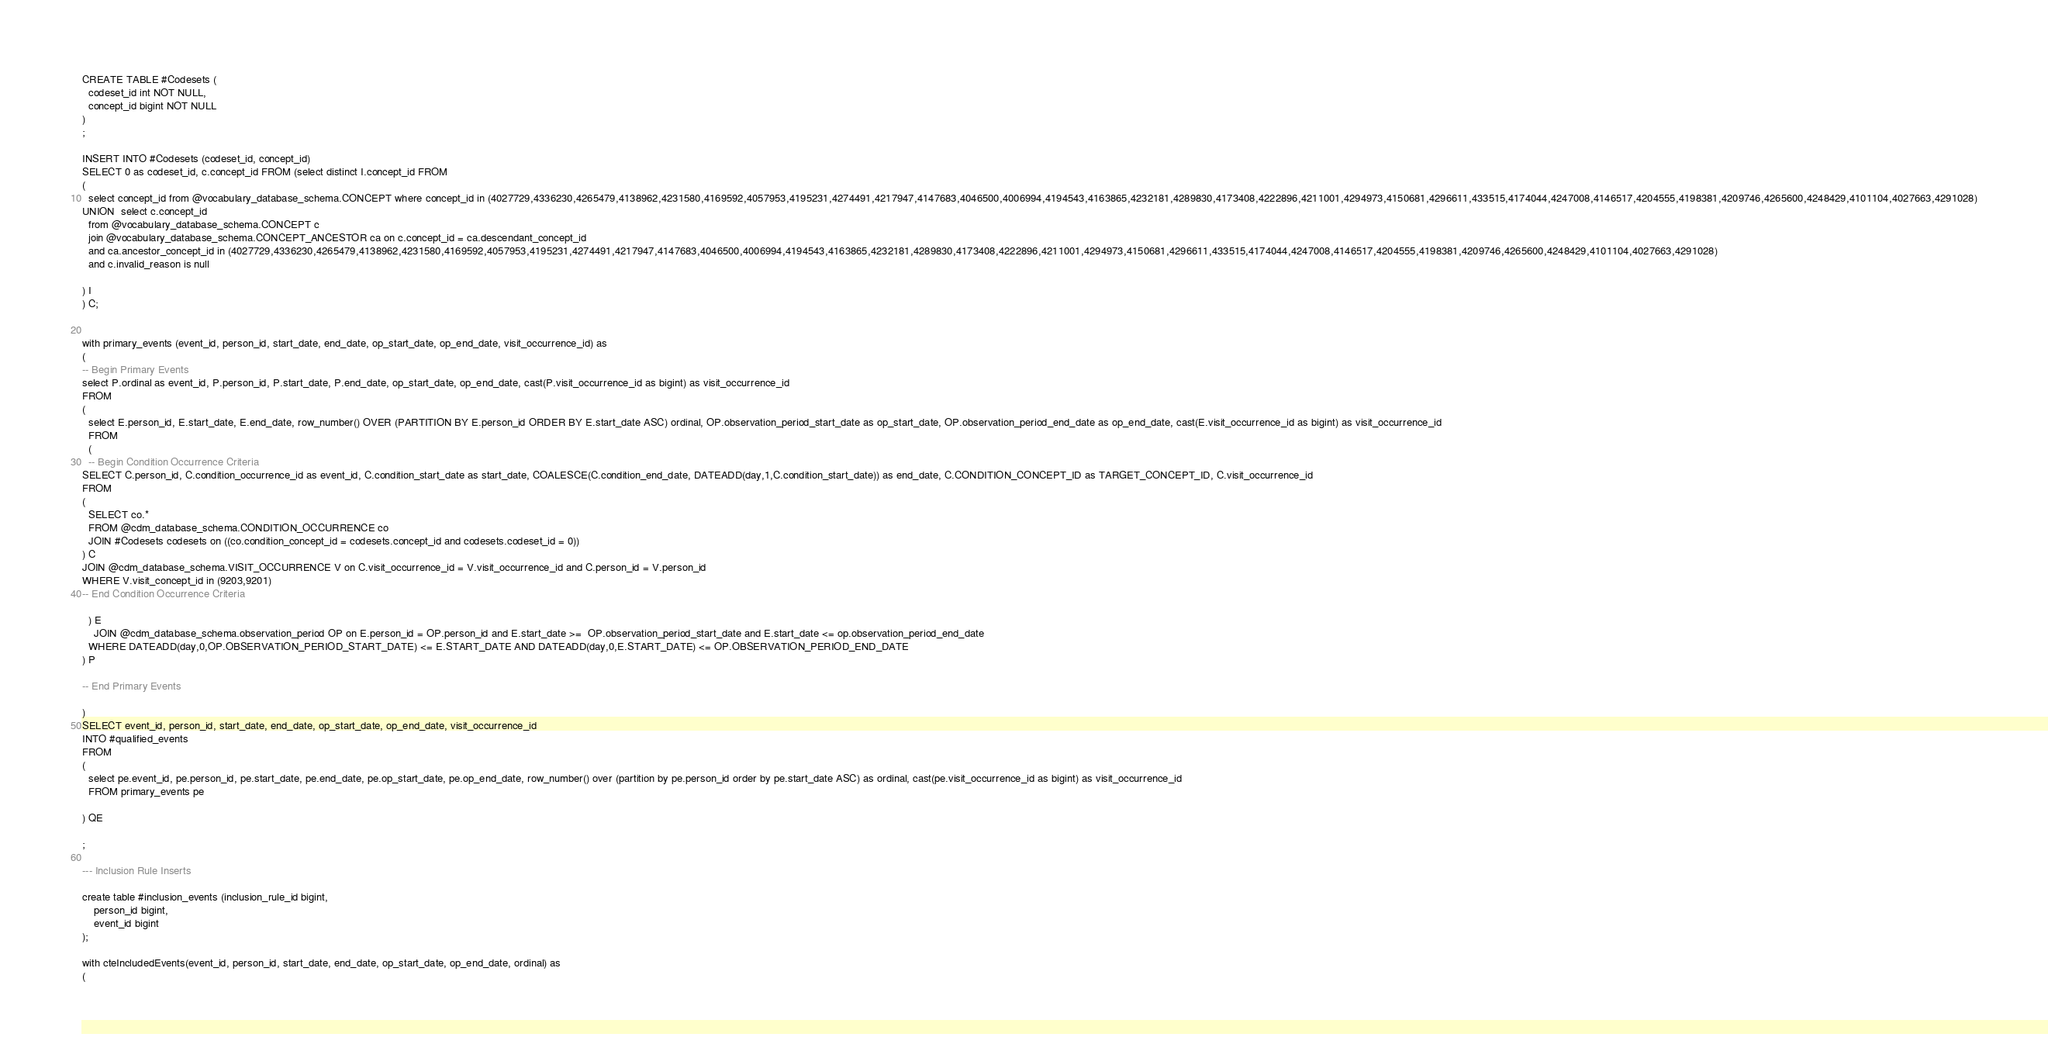Convert code to text. <code><loc_0><loc_0><loc_500><loc_500><_SQL_>CREATE TABLE #Codesets (
  codeset_id int NOT NULL,
  concept_id bigint NOT NULL
)
;

INSERT INTO #Codesets (codeset_id, concept_id)
SELECT 0 as codeset_id, c.concept_id FROM (select distinct I.concept_id FROM
( 
  select concept_id from @vocabulary_database_schema.CONCEPT where concept_id in (4027729,4336230,4265479,4138962,4231580,4169592,4057953,4195231,4274491,4217947,4147683,4046500,4006994,4194543,4163865,4232181,4289830,4173408,4222896,4211001,4294973,4150681,4296611,433515,4174044,4247008,4146517,4204555,4198381,4209746,4265600,4248429,4101104,4027663,4291028)
UNION  select c.concept_id
  from @vocabulary_database_schema.CONCEPT c
  join @vocabulary_database_schema.CONCEPT_ANCESTOR ca on c.concept_id = ca.descendant_concept_id
  and ca.ancestor_concept_id in (4027729,4336230,4265479,4138962,4231580,4169592,4057953,4195231,4274491,4217947,4147683,4046500,4006994,4194543,4163865,4232181,4289830,4173408,4222896,4211001,4294973,4150681,4296611,433515,4174044,4247008,4146517,4204555,4198381,4209746,4265600,4248429,4101104,4027663,4291028)
  and c.invalid_reason is null

) I
) C;


with primary_events (event_id, person_id, start_date, end_date, op_start_date, op_end_date, visit_occurrence_id) as
(
-- Begin Primary Events
select P.ordinal as event_id, P.person_id, P.start_date, P.end_date, op_start_date, op_end_date, cast(P.visit_occurrence_id as bigint) as visit_occurrence_id
FROM
(
  select E.person_id, E.start_date, E.end_date, row_number() OVER (PARTITION BY E.person_id ORDER BY E.start_date ASC) ordinal, OP.observation_period_start_date as op_start_date, OP.observation_period_end_date as op_end_date, cast(E.visit_occurrence_id as bigint) as visit_occurrence_id
  FROM 
  (
  -- Begin Condition Occurrence Criteria
SELECT C.person_id, C.condition_occurrence_id as event_id, C.condition_start_date as start_date, COALESCE(C.condition_end_date, DATEADD(day,1,C.condition_start_date)) as end_date, C.CONDITION_CONCEPT_ID as TARGET_CONCEPT_ID, C.visit_occurrence_id
FROM 
(
  SELECT co.* 
  FROM @cdm_database_schema.CONDITION_OCCURRENCE co
  JOIN #Codesets codesets on ((co.condition_concept_id = codesets.concept_id and codesets.codeset_id = 0))
) C
JOIN @cdm_database_schema.VISIT_OCCURRENCE V on C.visit_occurrence_id = V.visit_occurrence_id and C.person_id = V.person_id
WHERE V.visit_concept_id in (9203,9201)
-- End Condition Occurrence Criteria

  ) E
	JOIN @cdm_database_schema.observation_period OP on E.person_id = OP.person_id and E.start_date >=  OP.observation_period_start_date and E.start_date <= op.observation_period_end_date
  WHERE DATEADD(day,0,OP.OBSERVATION_PERIOD_START_DATE) <= E.START_DATE AND DATEADD(day,0,E.START_DATE) <= OP.OBSERVATION_PERIOD_END_DATE
) P

-- End Primary Events

)
SELECT event_id, person_id, start_date, end_date, op_start_date, op_end_date, visit_occurrence_id
INTO #qualified_events
FROM 
(
  select pe.event_id, pe.person_id, pe.start_date, pe.end_date, pe.op_start_date, pe.op_end_date, row_number() over (partition by pe.person_id order by pe.start_date ASC) as ordinal, cast(pe.visit_occurrence_id as bigint) as visit_occurrence_id
  FROM primary_events pe
  
) QE

;

--- Inclusion Rule Inserts

create table #inclusion_events (inclusion_rule_id bigint,
	person_id bigint,
	event_id bigint
);

with cteIncludedEvents(event_id, person_id, start_date, end_date, op_start_date, op_end_date, ordinal) as
(</code> 